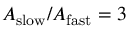<formula> <loc_0><loc_0><loc_500><loc_500>A _ { s l o w } / A _ { f a s t } = 3</formula> 